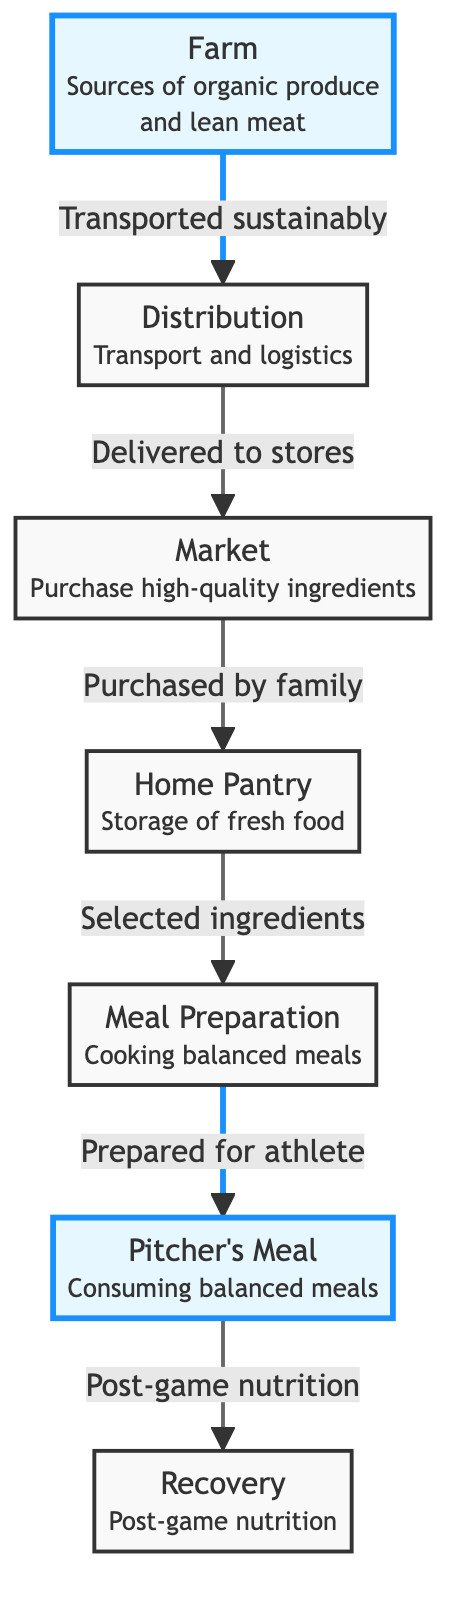What is the first stage of the food chain? The first stage of the food chain is displayed as "Farm" in the diagram, indicating the initial source of ingredients for the pitcher's diet.
Answer: Farm How many nodes are in the diagram? Counting the nodes, we have "Farm," "Distribution," "Market," "Home Pantry," "Meal Preparation," "Pitcher's Meal," and "Recovery," totaling seven nodes in the diagram.
Answer: 7 Which node indicates the storage of food? The node labeled "Home Pantry" represents the storage of fresh food in the diagram.
Answer: Home Pantry What connects "Market" to "Home Pantry"? The relationship indicated between "Market" and "Home Pantry" is through the action labeled "Purchased by family," showing how food moves from the market to home.
Answer: Purchased by family What is the last step after the "Pitcher's Meal"? The final step after "Pitcher’s Meal" is "Recovery," which involves post-game nutrition to help with recovery.
Answer: Recovery What type of produce is mentioned in the "Farm" node? The "Farm" node specifies that it is a source of "organic produce," highlighting the emphasis on quality ingredients.
Answer: organic produce How does food get from "Farm" to "Market"? The connection between "Farm" and "Market" is established through the action "Transported sustainably," indicating the method by which the food is delivered.
Answer: Transported sustainably Which node follows "Meal Preparation"? The node that follows "Meal Preparation" is "Pitcher's Meal," indicating the outcome of the meal preparation process.
Answer: Pitcher's Meal What is the purpose of "Recovery"? The purpose of the "Recovery" node is to address "Post-game nutrition" for the pitcher, highlighting its importance after games.
Answer: Post-game nutrition 